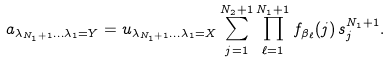Convert formula to latex. <formula><loc_0><loc_0><loc_500><loc_500>a _ { \lambda _ { N _ { 1 } + 1 } \dots \lambda _ { 1 } = Y } = u _ { \lambda _ { N _ { 1 } + 1 } \dots \lambda _ { 1 } = X } \sum _ { j = 1 } ^ { N _ { 2 } + 1 } \prod _ { \ell = 1 } ^ { N _ { 1 } + 1 } f _ { \beta _ { \ell } } ( j ) \, s _ { j } ^ { N _ { 1 } + 1 } .</formula> 